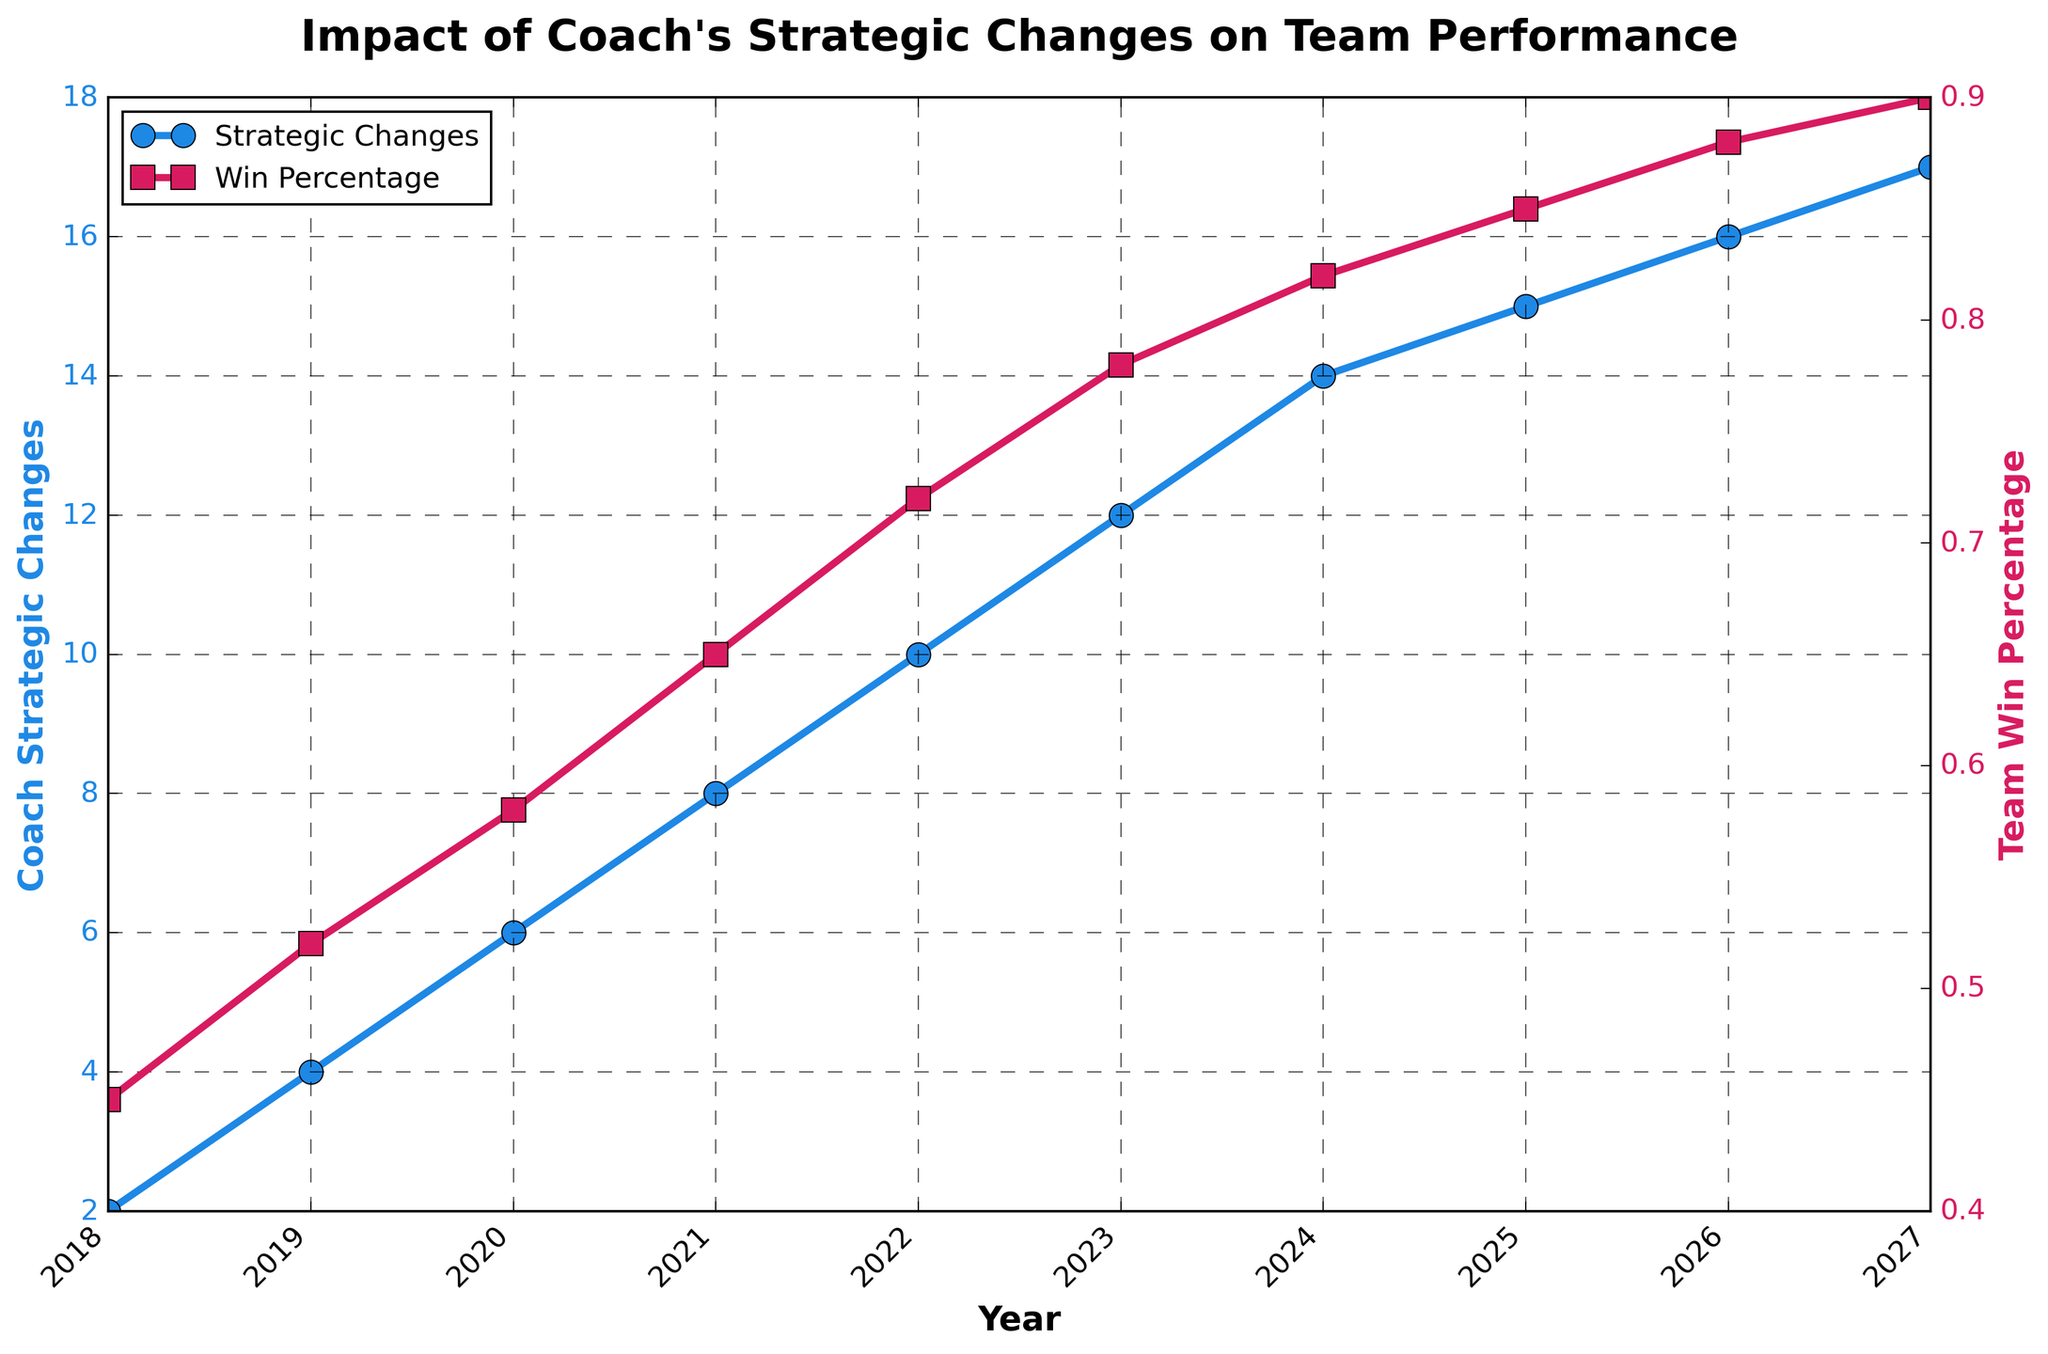What is the trend in the number of strategic changes by the coach between 2018 and 2027? Review the plot of "Coach Strategic Changes" (blue line) over the years. Observe that the number of changes consistently increases from 2 in 2018 to 17 in 2027.
Answer: Increasing trend How does the win percentage change relative to the number of strategic changes? Examine the relationship between the "Team Win Percentage" (red line) and the "Coach Strategic Changes" (blue line). Notice that as the number of strategic changes increases from 2 to 17, the win percentage also rises from 0.45 to 0.90.
Answer: Direct correlation By how much did the team win percentage increase from 2018 to 2023? Identify the win percentage values in 2018 (0.45) and 2023 (0.78). Calculate the increase: 0.78 - 0.45 = 0.33.
Answer: 0.33 In which year did the team win percentage first reach or surpass 0.8? Look at the "Team Win Percentage" (red line) and find the first year it reaches or exceeds 0.80. This happens in 2024 when the percentage is 0.82.
Answer: 2024 What was the difference in the number of strategic changes between 2022 and 2025? Identify the values for "Coach Strategic Changes" in 2022 (10) and 2025 (15). Calculate the difference: 15 - 10 = 5.
Answer: 5 How does the change in win percentage from 2020 to 2021 compare to the change from 2025 to 2026? Calculate the change in win percentage for each period: 2020 to 2021: 0.65 - 0.58 = 0.07, 2025 to 2026: 0.88 - 0.85 = 0.03. Compare the changes: 0.07 is greater than 0.03.
Answer: Greater in 2020 to 2021 During which year did the coach make exactly 15 strategic changes? Look for the year where the "Coach Strategic Changes" (blue line) equals 15. This happens in 2025.
Answer: 2025 What is the average team win percentage from 2018 to 2022? Sum the win percentages from 2018 to 2022 (0.45 + 0.52 + 0.58 + 0.65 + 0.72) and divide by the number of years (5). (0.45 + 0.52 + 0.58 + 0.65 + 0.72) / 5 = 2.92 / 5 = 0.584.
Answer: 0.584 How many times did the coach make more than 10 strategic changes in a given year? Identify the years with more than 10 strategic changes (2023, 2024, 2025, 2026, 2027). Count them: 5 times.
Answer: 5 Which year had the smallest increase in win percentage compared to the previous year? Calculate the year-over-year increases in win percentage and identify the smallest one. The smallest increase is 0.82 - 0.85 = 0.03 from 2025 to 2026.
Answer: 2025 to 2026 